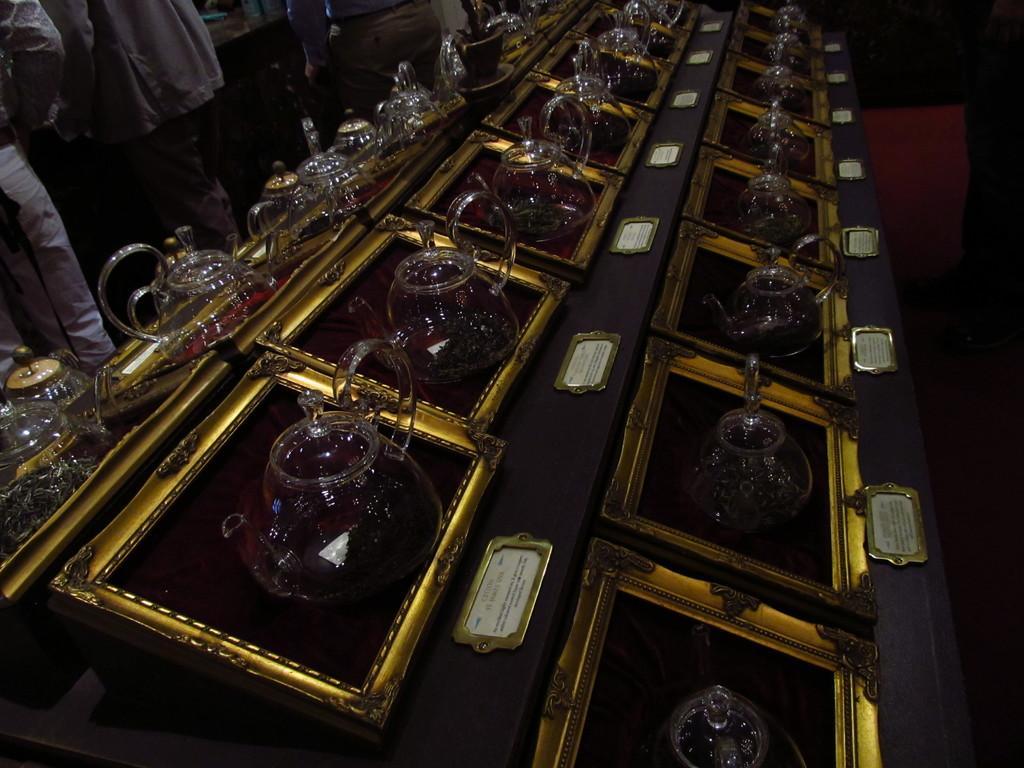Please provide a concise description of this image. In this image I can see some jugs on the desk. On the left side I can see some people. 